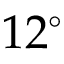Convert formula to latex. <formula><loc_0><loc_0><loc_500><loc_500>1 2 ^ { \circ }</formula> 